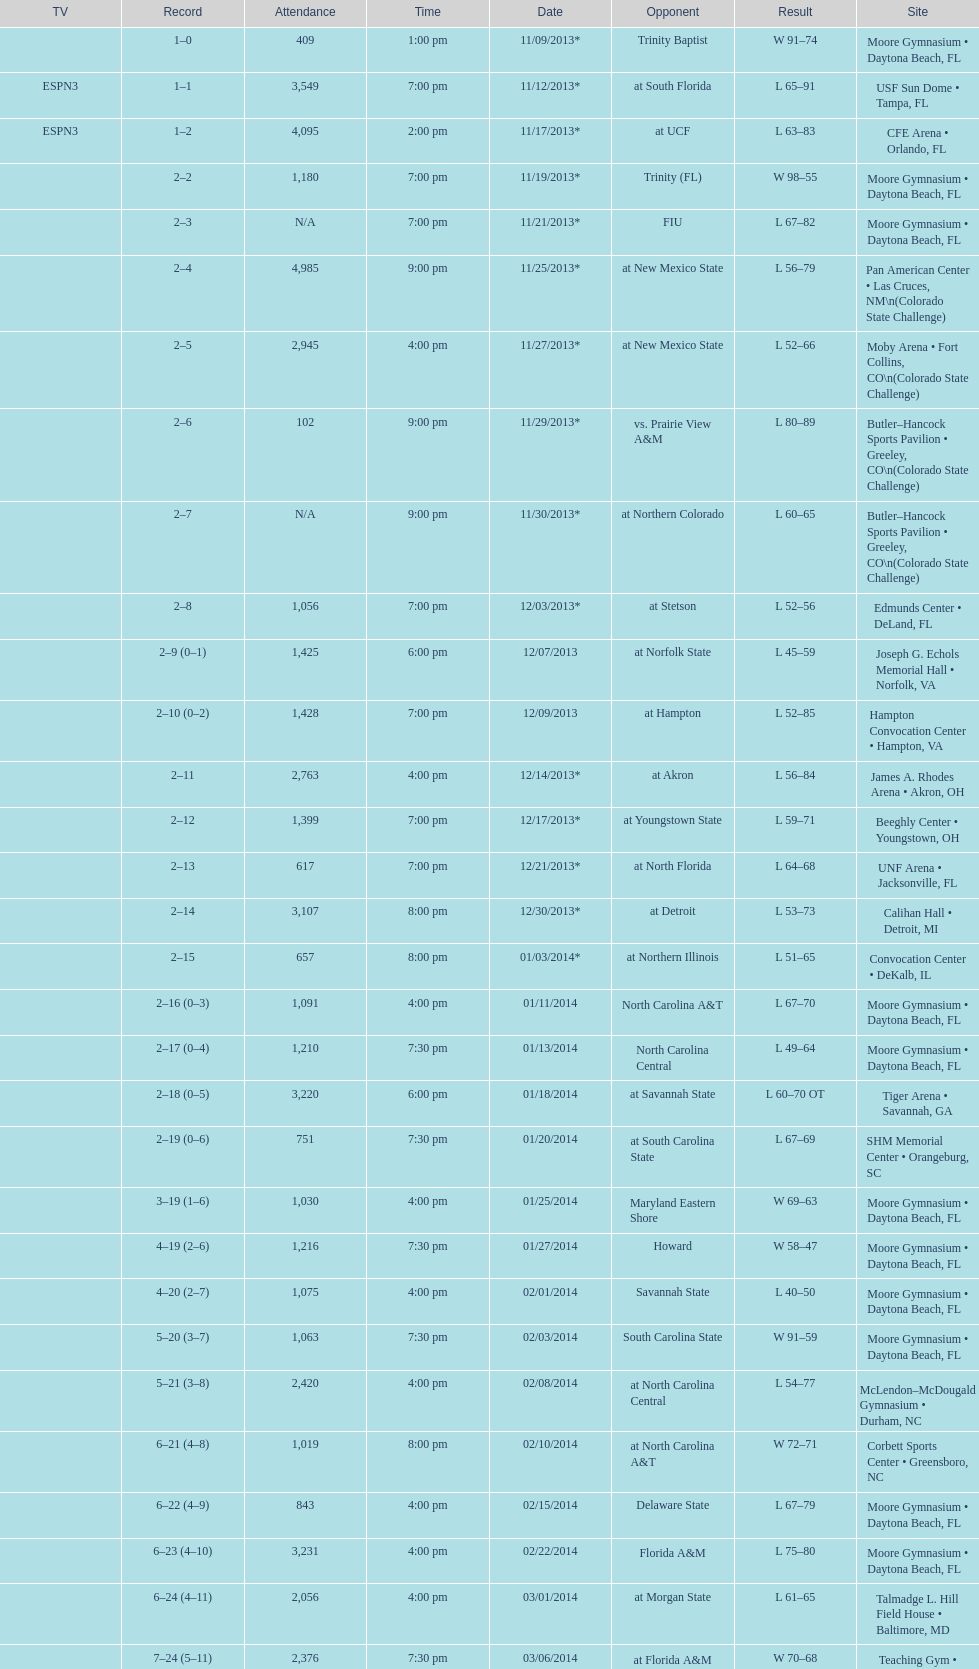Give me the full table as a dictionary. {'header': ['TV', 'Record', 'Attendance', 'Time', 'Date', 'Opponent', 'Result', 'Site'], 'rows': [['', '1–0', '409', '1:00 pm', '11/09/2013*', 'Trinity Baptist', 'W\xa091–74', 'Moore Gymnasium • Daytona Beach, FL'], ['ESPN3', '1–1', '3,549', '7:00 pm', '11/12/2013*', 'at\xa0South Florida', 'L\xa065–91', 'USF Sun Dome • Tampa, FL'], ['ESPN3', '1–2', '4,095', '2:00 pm', '11/17/2013*', 'at\xa0UCF', 'L\xa063–83', 'CFE Arena • Orlando, FL'], ['', '2–2', '1,180', '7:00 pm', '11/19/2013*', 'Trinity (FL)', 'W\xa098–55', 'Moore Gymnasium • Daytona Beach, FL'], ['', '2–3', 'N/A', '7:00 pm', '11/21/2013*', 'FIU', 'L\xa067–82', 'Moore Gymnasium • Daytona Beach, FL'], ['', '2–4', '4,985', '9:00 pm', '11/25/2013*', 'at\xa0New Mexico State', 'L\xa056–79', 'Pan American Center • Las Cruces, NM\\n(Colorado State Challenge)'], ['', '2–5', '2,945', '4:00 pm', '11/27/2013*', 'at\xa0New Mexico State', 'L\xa052–66', 'Moby Arena • Fort Collins, CO\\n(Colorado State Challenge)'], ['', '2–6', '102', '9:00 pm', '11/29/2013*', 'vs.\xa0Prairie View A&M', 'L\xa080–89', 'Butler–Hancock Sports Pavilion • Greeley, CO\\n(Colorado State Challenge)'], ['', '2–7', 'N/A', '9:00 pm', '11/30/2013*', 'at\xa0Northern Colorado', 'L\xa060–65', 'Butler–Hancock Sports Pavilion • Greeley, CO\\n(Colorado State Challenge)'], ['', '2–8', '1,056', '7:00 pm', '12/03/2013*', 'at\xa0Stetson', 'L\xa052–56', 'Edmunds Center • DeLand, FL'], ['', '2–9 (0–1)', '1,425', '6:00 pm', '12/07/2013', 'at\xa0Norfolk State', 'L\xa045–59', 'Joseph G. Echols Memorial Hall • Norfolk, VA'], ['', '2–10 (0–2)', '1,428', '7:00 pm', '12/09/2013', 'at\xa0Hampton', 'L\xa052–85', 'Hampton Convocation Center • Hampton, VA'], ['', '2–11', '2,763', '4:00 pm', '12/14/2013*', 'at\xa0Akron', 'L\xa056–84', 'James A. Rhodes Arena • Akron, OH'], ['', '2–12', '1,399', '7:00 pm', '12/17/2013*', 'at\xa0Youngstown State', 'L\xa059–71', 'Beeghly Center • Youngstown, OH'], ['', '2–13', '617', '7:00 pm', '12/21/2013*', 'at\xa0North Florida', 'L\xa064–68', 'UNF Arena • Jacksonville, FL'], ['', '2–14', '3,107', '8:00 pm', '12/30/2013*', 'at\xa0Detroit', 'L\xa053–73', 'Calihan Hall • Detroit, MI'], ['', '2–15', '657', '8:00 pm', '01/03/2014*', 'at\xa0Northern Illinois', 'L\xa051–65', 'Convocation Center • DeKalb, IL'], ['', '2–16 (0–3)', '1,091', '4:00 pm', '01/11/2014', 'North Carolina A&T', 'L\xa067–70', 'Moore Gymnasium • Daytona Beach, FL'], ['', '2–17 (0–4)', '1,210', '7:30 pm', '01/13/2014', 'North Carolina Central', 'L\xa049–64', 'Moore Gymnasium • Daytona Beach, FL'], ['', '2–18 (0–5)', '3,220', '6:00 pm', '01/18/2014', 'at\xa0Savannah State', 'L\xa060–70\xa0OT', 'Tiger Arena • Savannah, GA'], ['', '2–19 (0–6)', '751', '7:30 pm', '01/20/2014', 'at\xa0South Carolina State', 'L\xa067–69', 'SHM Memorial Center • Orangeburg, SC'], ['', '3–19 (1–6)', '1,030', '4:00 pm', '01/25/2014', 'Maryland Eastern Shore', 'W\xa069–63', 'Moore Gymnasium • Daytona Beach, FL'], ['', '4–19 (2–6)', '1,216', '7:30 pm', '01/27/2014', 'Howard', 'W\xa058–47', 'Moore Gymnasium • Daytona Beach, FL'], ['', '4–20 (2–7)', '1,075', '4:00 pm', '02/01/2014', 'Savannah State', 'L\xa040–50', 'Moore Gymnasium • Daytona Beach, FL'], ['', '5–20 (3–7)', '1,063', '7:30 pm', '02/03/2014', 'South Carolina State', 'W\xa091–59', 'Moore Gymnasium • Daytona Beach, FL'], ['', '5–21 (3–8)', '2,420', '4:00 pm', '02/08/2014', 'at\xa0North Carolina Central', 'L\xa054–77', 'McLendon–McDougald Gymnasium • Durham, NC'], ['', '6–21 (4–8)', '1,019', '8:00 pm', '02/10/2014', 'at\xa0North Carolina A&T', 'W\xa072–71', 'Corbett Sports Center • Greensboro, NC'], ['', '6–22 (4–9)', '843', '4:00 pm', '02/15/2014', 'Delaware State', 'L\xa067–79', 'Moore Gymnasium • Daytona Beach, FL'], ['', '6–23 (4–10)', '3,231', '4:00 pm', '02/22/2014', 'Florida A&M', 'L\xa075–80', 'Moore Gymnasium • Daytona Beach, FL'], ['', '6–24 (4–11)', '2,056', '4:00 pm', '03/01/2014', 'at\xa0Morgan State', 'L\xa061–65', 'Talmadge L. Hill Field House • Baltimore, MD'], ['', '7–24 (5–11)', '2,376', '7:30 pm', '03/06/2014', 'at\xa0Florida A&M', 'W\xa070–68', 'Teaching Gym • Tallahassee, FL'], ['', '7–25', '4,658', '6:30 pm', '03/11/2014', 'vs.\xa0Coppin State', 'L\xa068–75', 'Norfolk Scope • Norfolk, VA\\n(First round)']]} What is the total attendance on 11/09/2013? 409. 